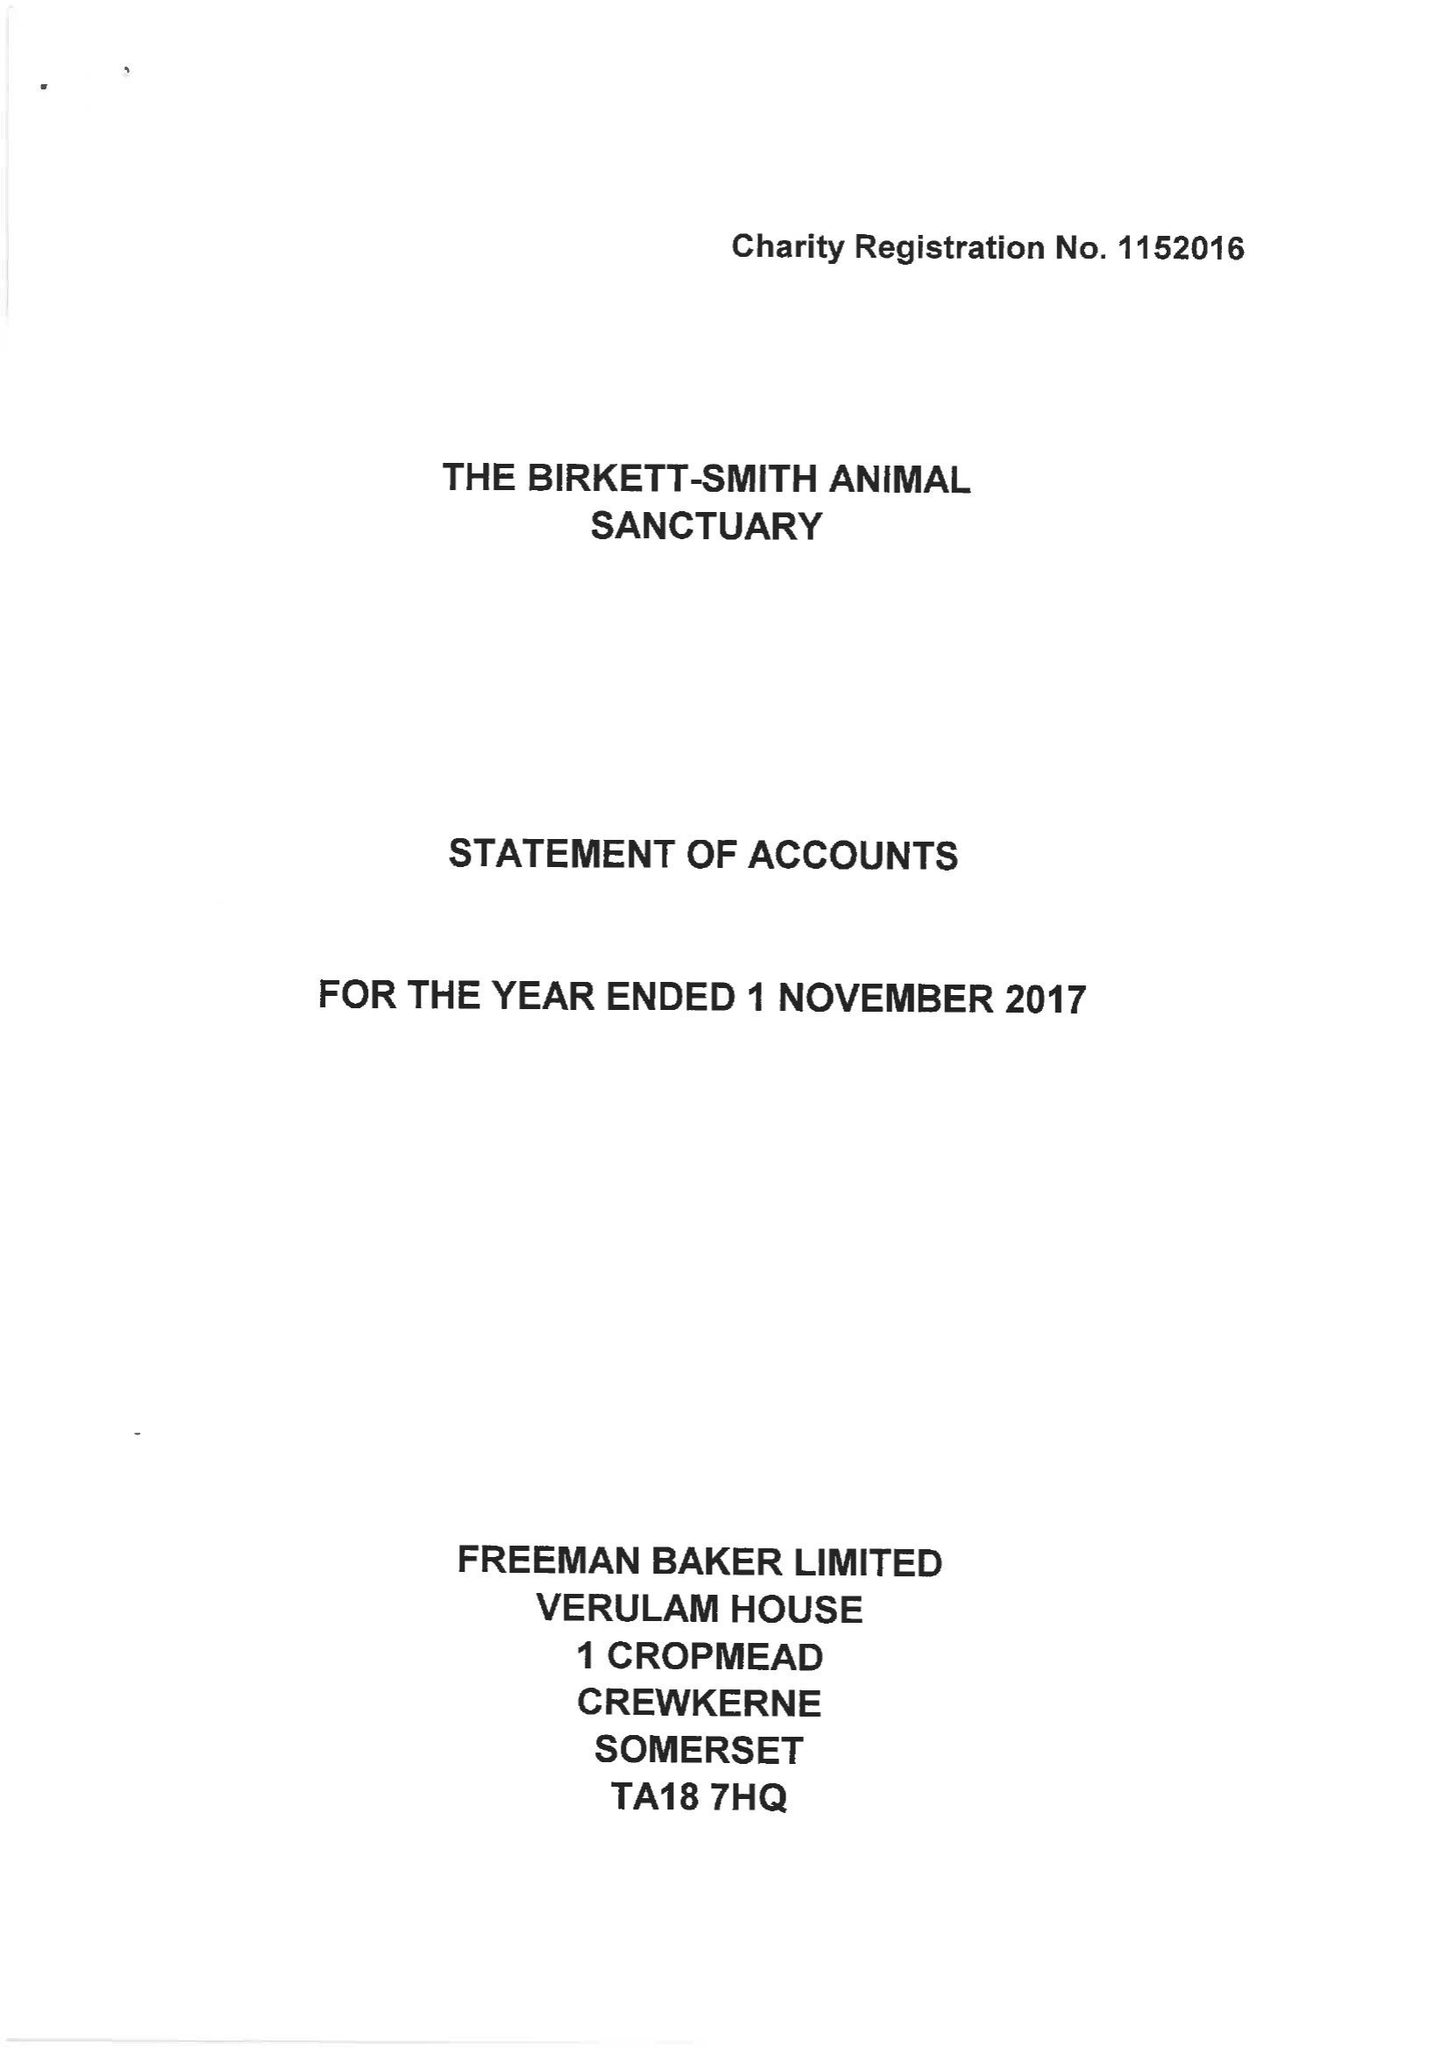What is the value for the income_annually_in_british_pounds?
Answer the question using a single word or phrase. 140784.00 